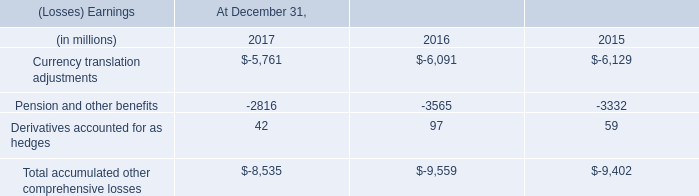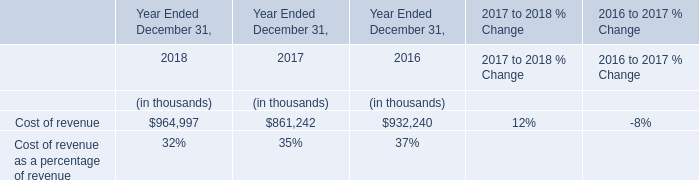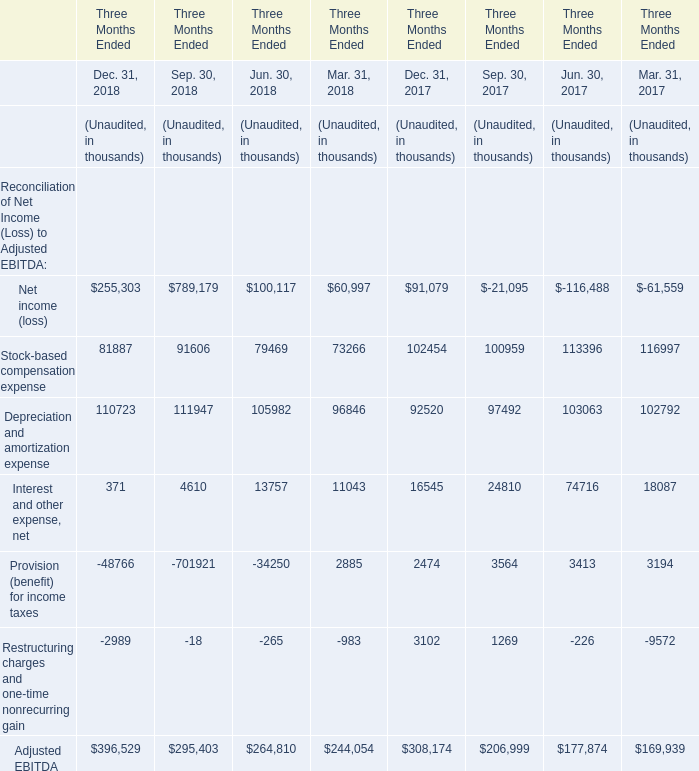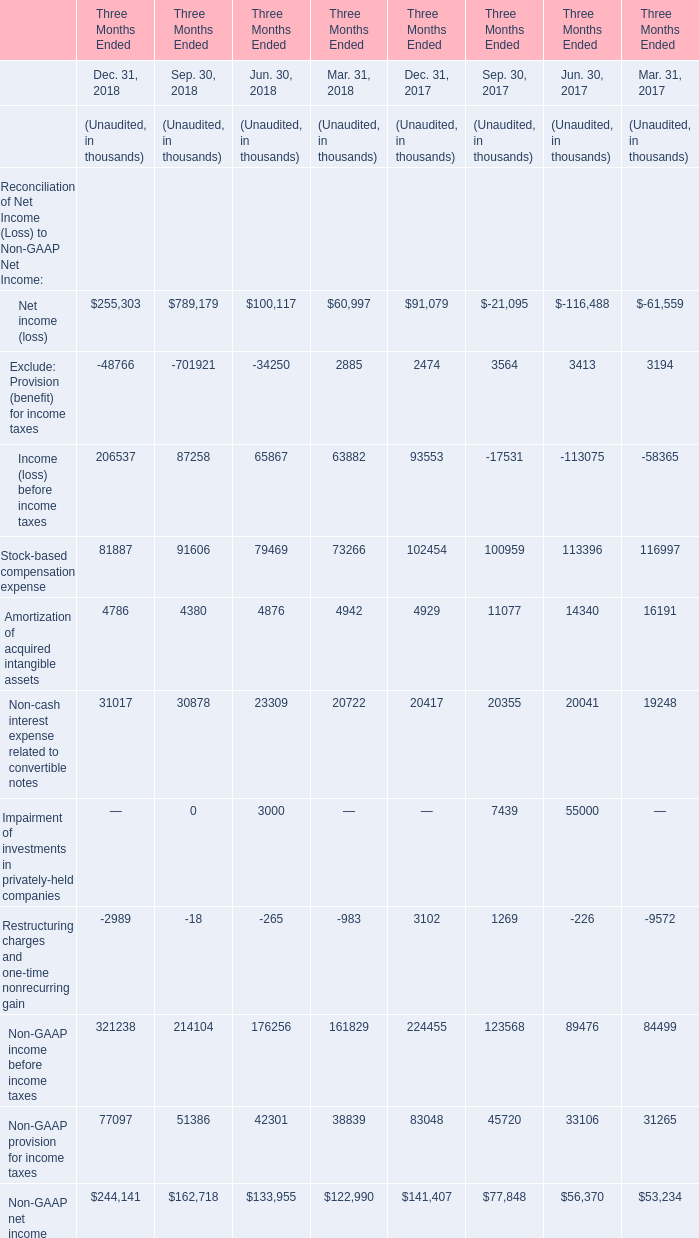What is the ratio of all elements that are smaller than 100000 to the sum of elements, for Jun. 30, 2018? 
Computations: ((((79469 + 13757) - 34250) - 265) / 264810)
Answer: 0.22171. 